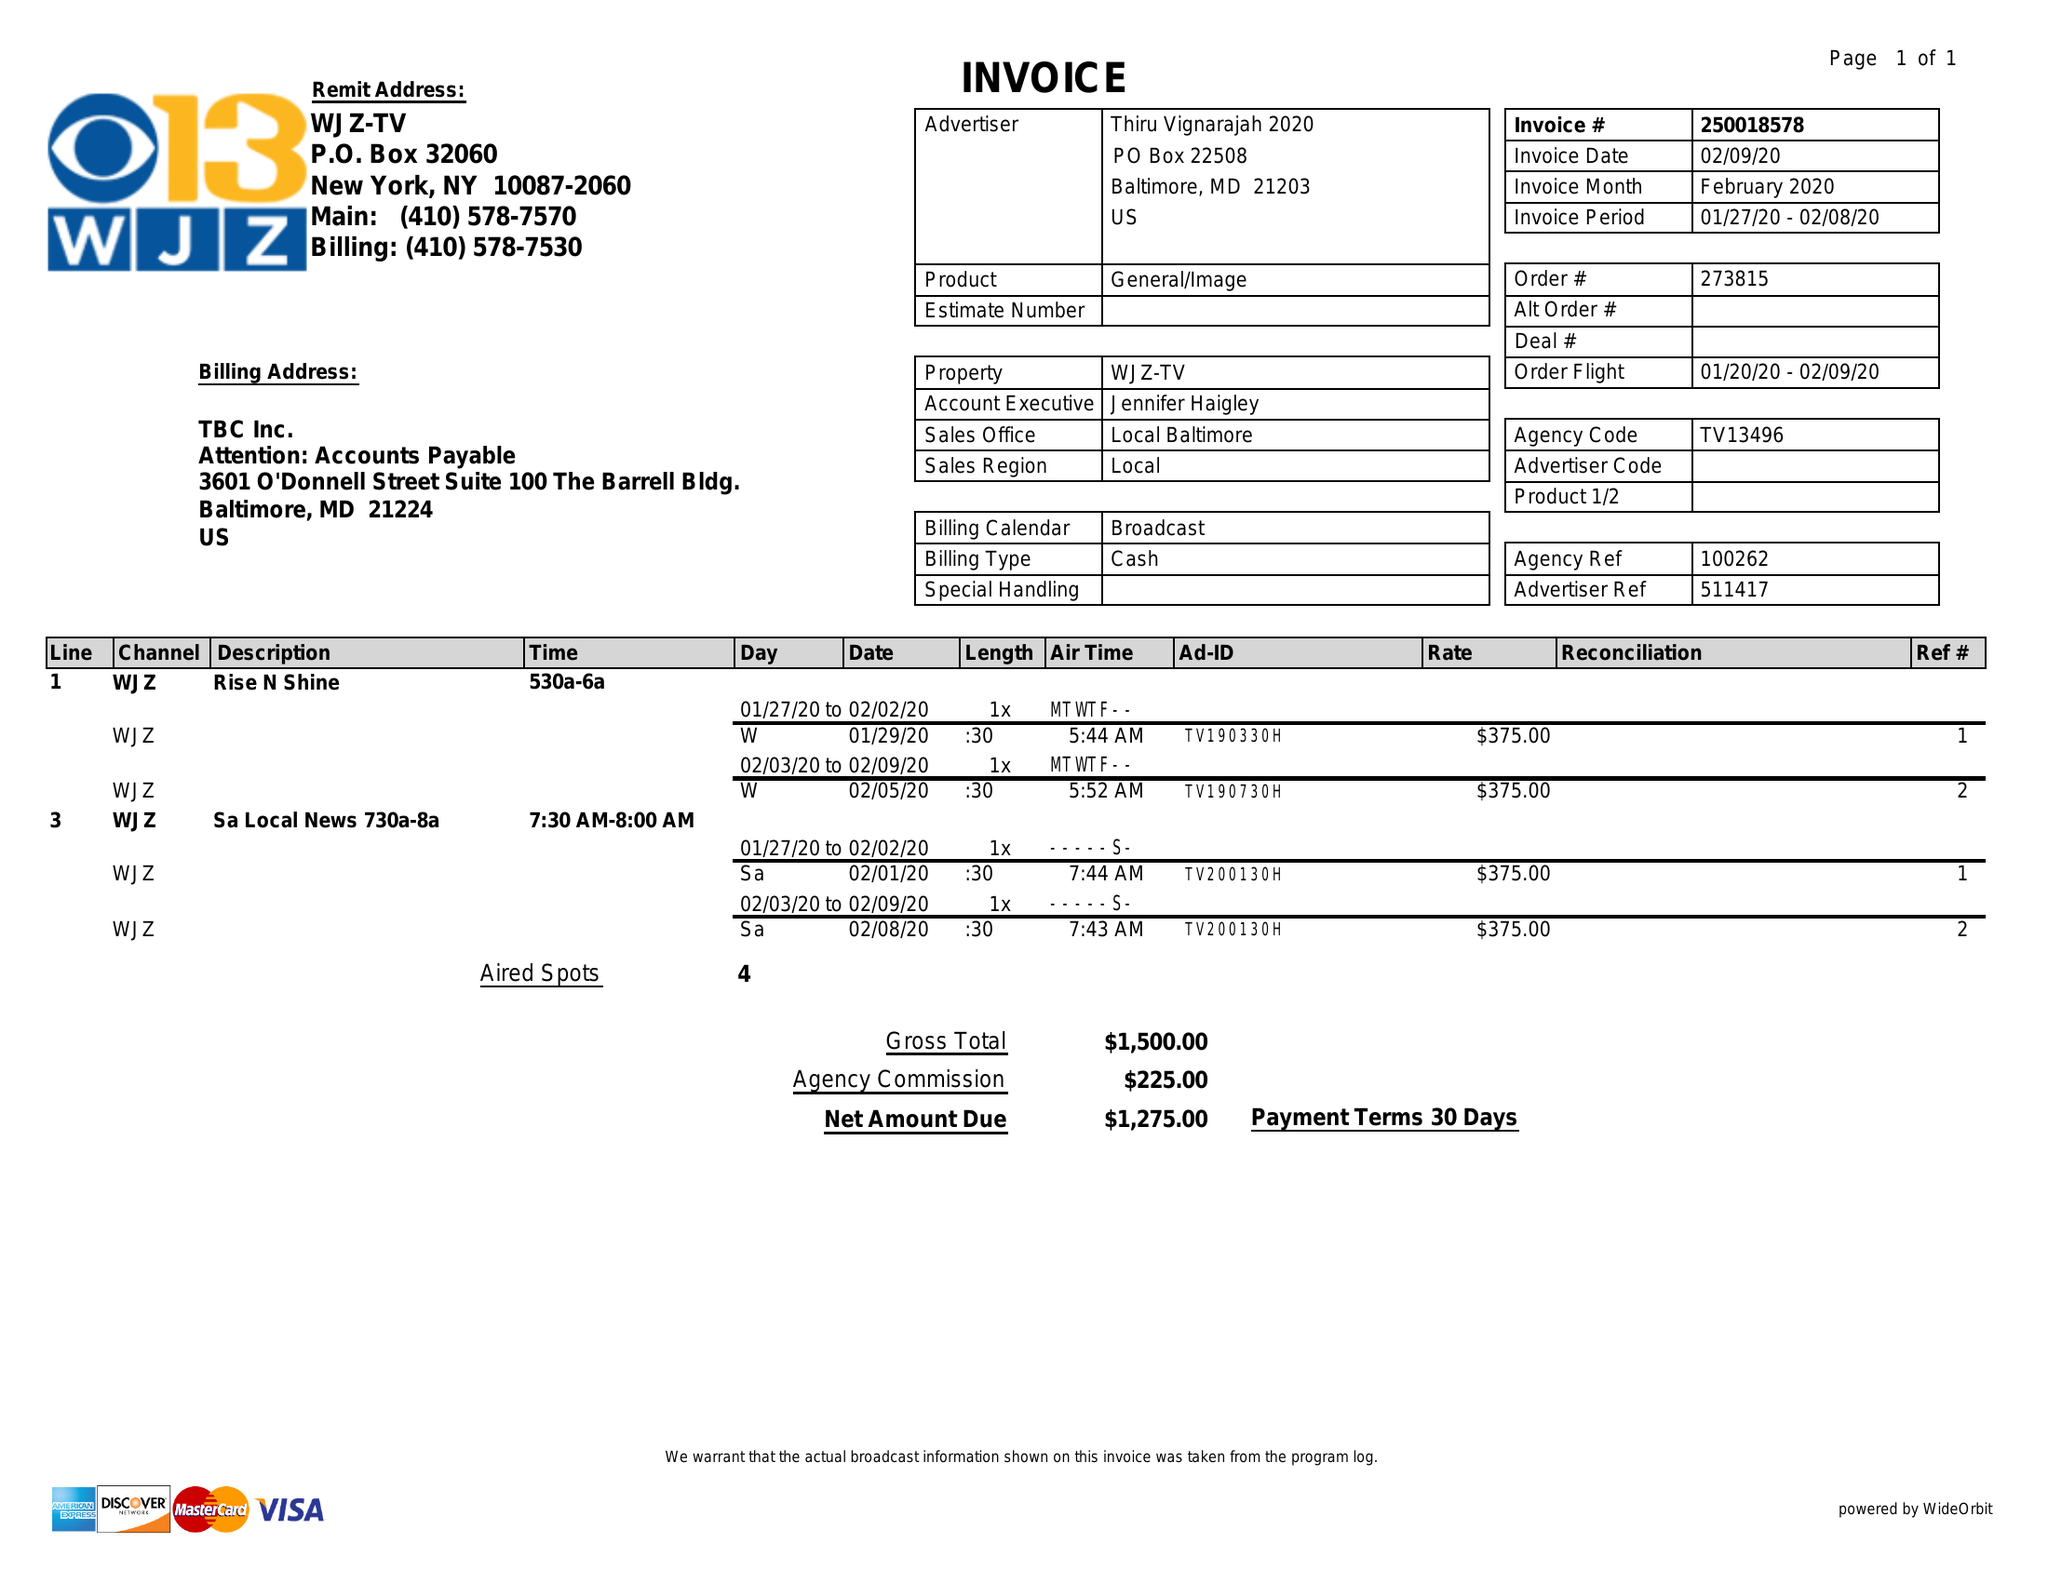What is the value for the contract_num?
Answer the question using a single word or phrase. 250018578 